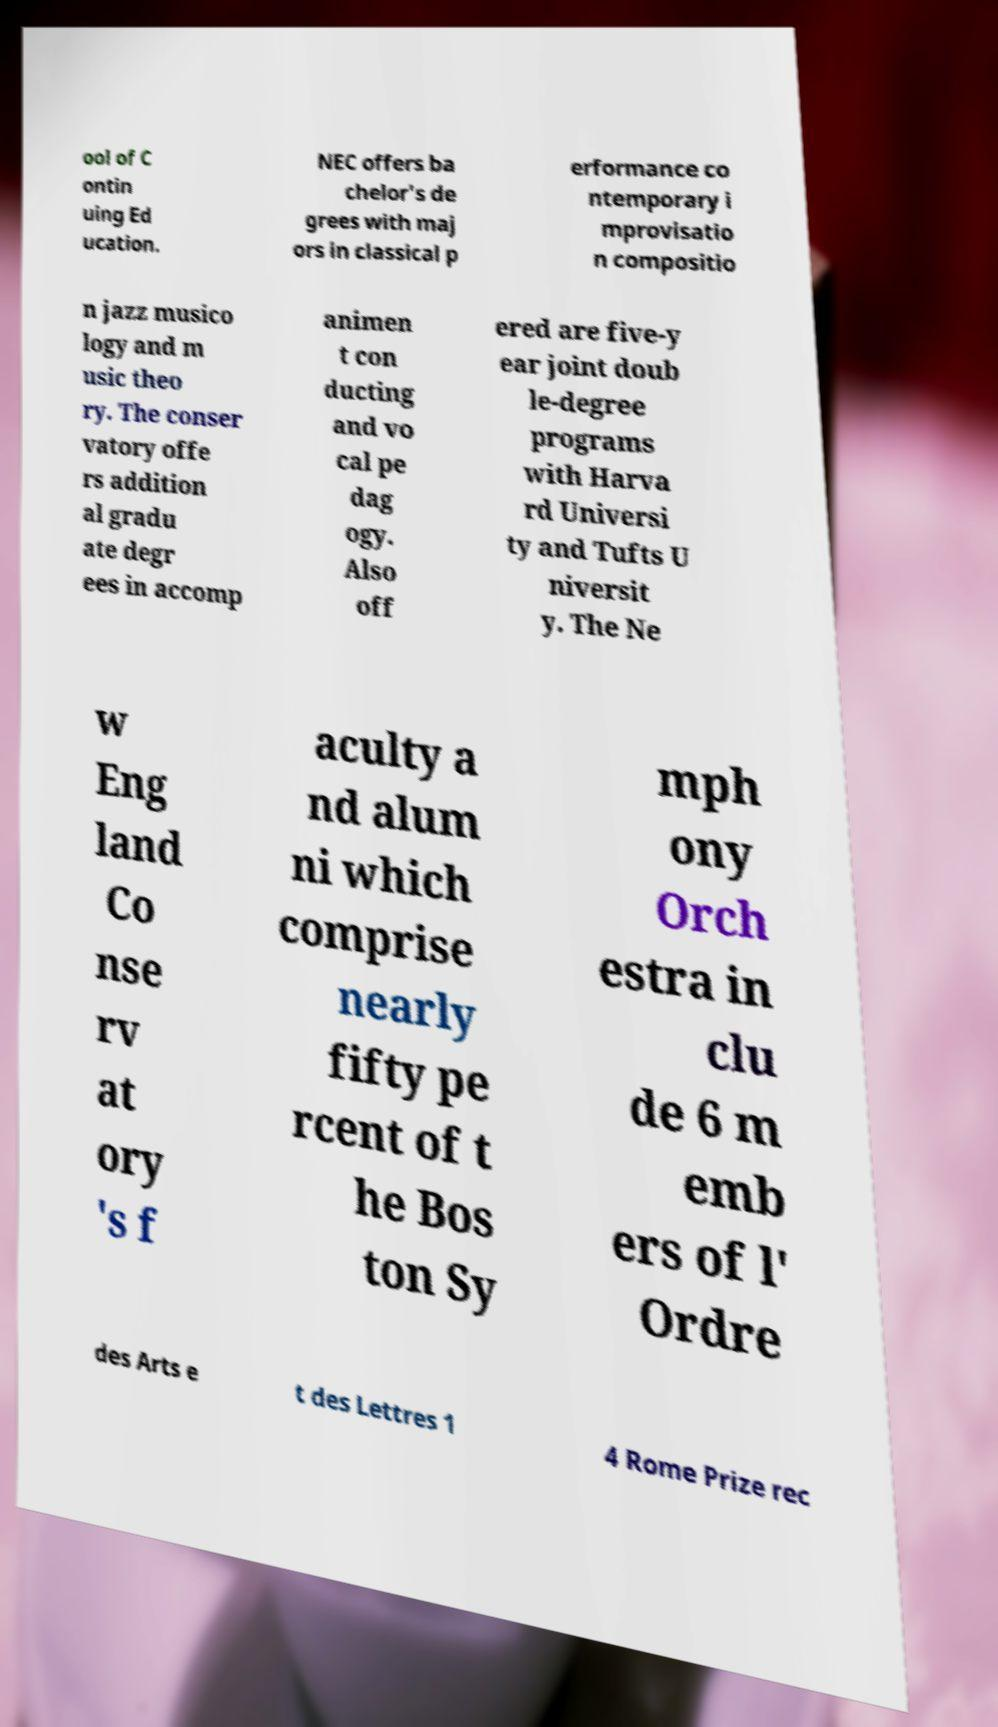What messages or text are displayed in this image? I need them in a readable, typed format. ool of C ontin uing Ed ucation. NEC offers ba chelor's de grees with maj ors in classical p erformance co ntemporary i mprovisatio n compositio n jazz musico logy and m usic theo ry. The conser vatory offe rs addition al gradu ate degr ees in accomp animen t con ducting and vo cal pe dag ogy. Also off ered are five-y ear joint doub le-degree programs with Harva rd Universi ty and Tufts U niversit y. The Ne w Eng land Co nse rv at ory 's f aculty a nd alum ni which comprise nearly fifty pe rcent of t he Bos ton Sy mph ony Orch estra in clu de 6 m emb ers of l' Ordre des Arts e t des Lettres 1 4 Rome Prize rec 